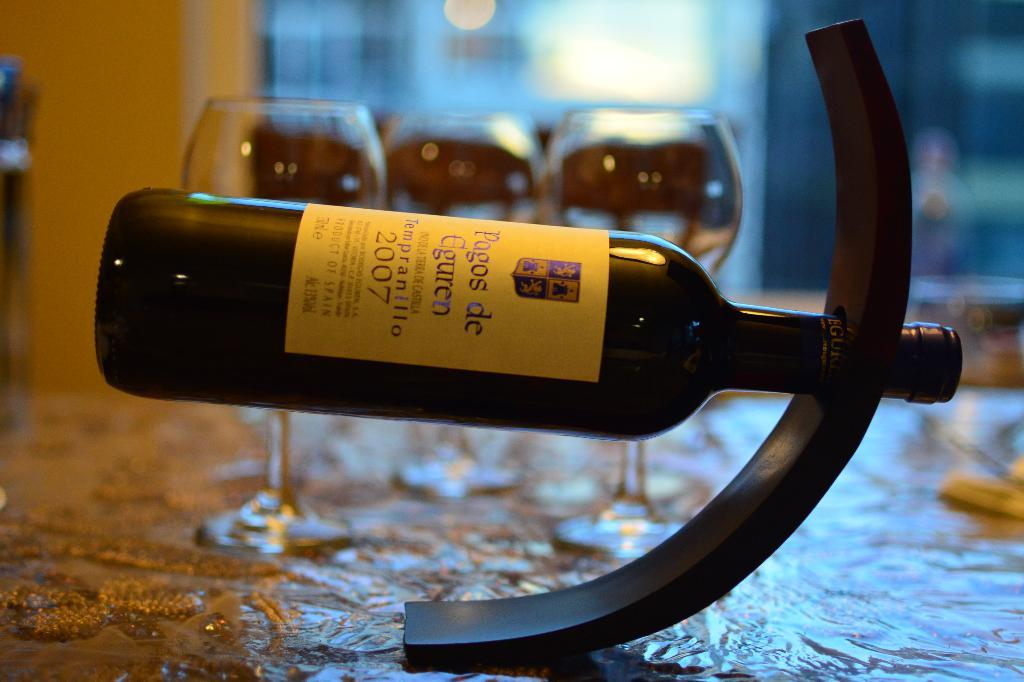<image>
Share a concise interpretation of the image provided. A bottle of Pagos De Eguren sits on its side. 